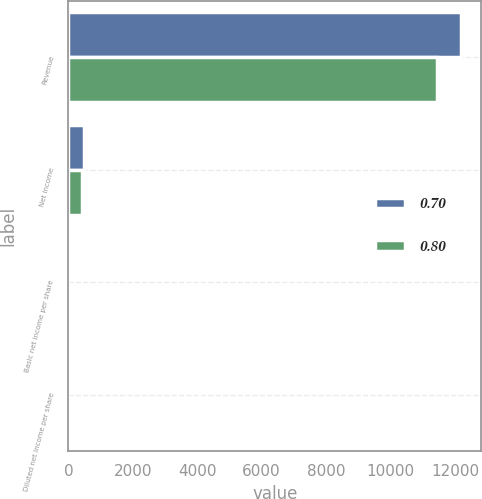<chart> <loc_0><loc_0><loc_500><loc_500><stacked_bar_chart><ecel><fcel>Revenue<fcel>Net income<fcel>Basic net income per share<fcel>Diluted net income per share<nl><fcel>0.7<fcel>12199<fcel>489<fcel>0.84<fcel>0.8<nl><fcel>0.8<fcel>11452<fcel>419<fcel>0.74<fcel>0.7<nl></chart> 